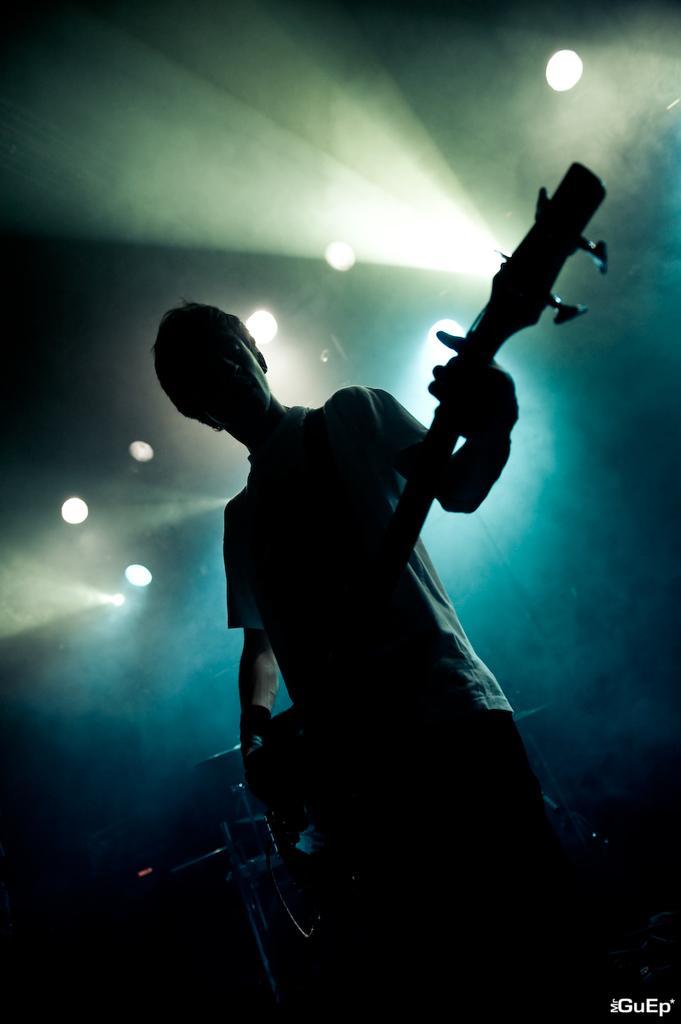Can you describe this image briefly? In this picture there is a person standing and holding the guitar. At the back there are drums. At the top there are lights. At the bottom right there is a text. 